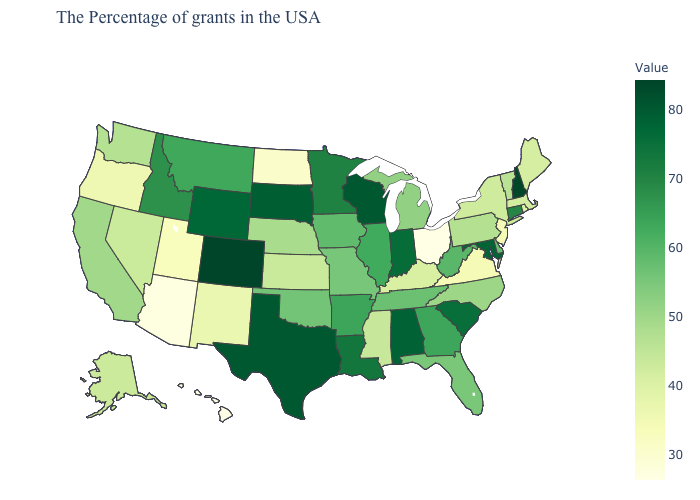Which states hav the highest value in the Northeast?
Give a very brief answer. New Hampshire. Which states hav the highest value in the South?
Short answer required. Texas. Does the map have missing data?
Give a very brief answer. No. Which states have the lowest value in the Northeast?
Write a very short answer. New Jersey. 